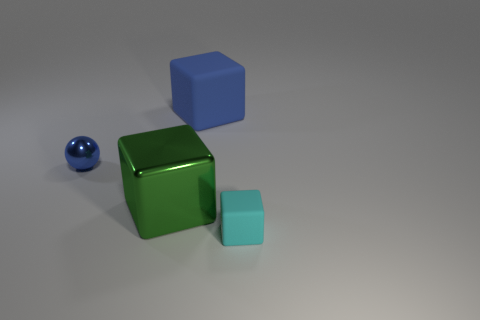There is a big green object that is the same material as the sphere; what is its shape?
Offer a terse response. Cube. Is there any other thing of the same color as the tiny cube?
Keep it short and to the point. No. Are there more small cyan blocks on the right side of the big blue matte block than blue shiny spheres in front of the tiny blue shiny sphere?
Ensure brevity in your answer.  Yes. What number of metallic blocks have the same size as the blue ball?
Keep it short and to the point. 0. Is the number of tiny cyan matte things that are behind the small cyan block less than the number of cyan matte objects behind the green object?
Your response must be concise. No. Is there a tiny thing that has the same shape as the big green metal object?
Give a very brief answer. Yes. Does the green thing have the same shape as the blue rubber object?
Provide a succinct answer. Yes. What number of large objects are balls or shiny blocks?
Offer a very short reply. 1. Are there more big shiny things than shiny objects?
Keep it short and to the point. No. What is the size of the object that is made of the same material as the sphere?
Ensure brevity in your answer.  Large. 